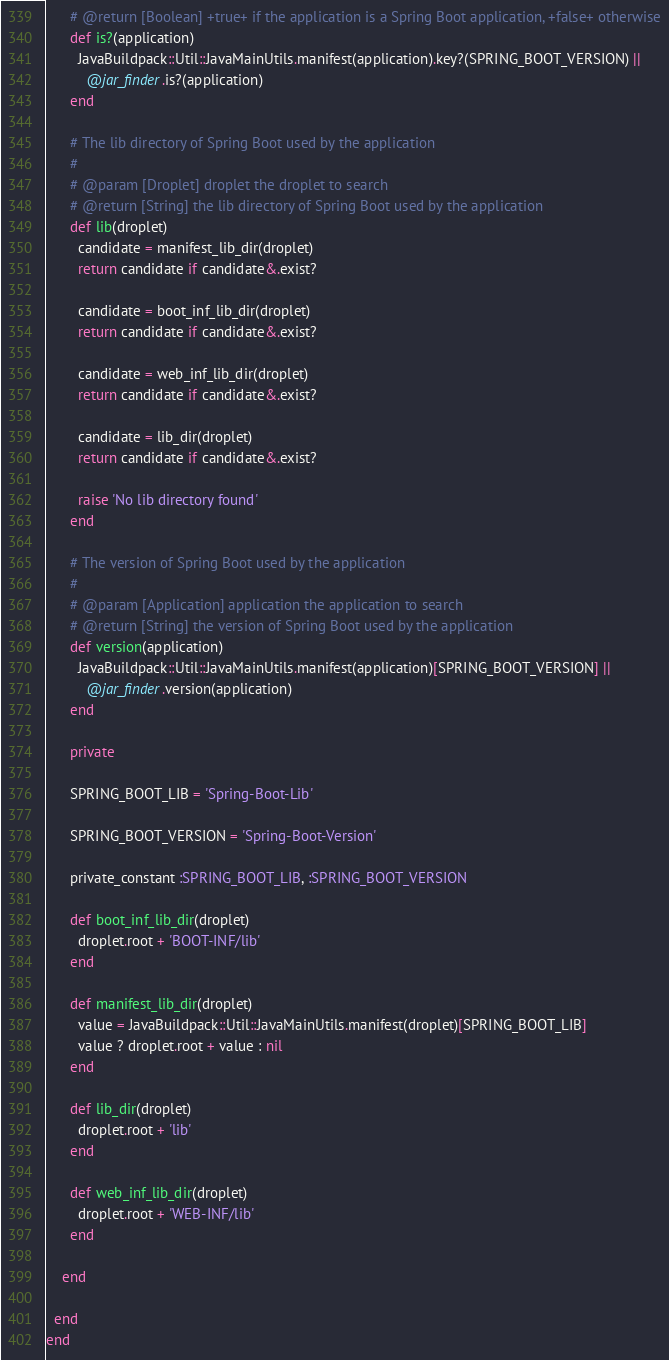Convert code to text. <code><loc_0><loc_0><loc_500><loc_500><_Ruby_>      # @return [Boolean] +true+ if the application is a Spring Boot application, +false+ otherwise
      def is?(application)
        JavaBuildpack::Util::JavaMainUtils.manifest(application).key?(SPRING_BOOT_VERSION) ||
          @jar_finder.is?(application)
      end

      # The lib directory of Spring Boot used by the application
      #
      # @param [Droplet] droplet the droplet to search
      # @return [String] the lib directory of Spring Boot used by the application
      def lib(droplet)
        candidate = manifest_lib_dir(droplet)
        return candidate if candidate&.exist?

        candidate = boot_inf_lib_dir(droplet)
        return candidate if candidate&.exist?

        candidate = web_inf_lib_dir(droplet)
        return candidate if candidate&.exist?

        candidate = lib_dir(droplet)
        return candidate if candidate&.exist?

        raise 'No lib directory found'
      end

      # The version of Spring Boot used by the application
      #
      # @param [Application] application the application to search
      # @return [String] the version of Spring Boot used by the application
      def version(application)
        JavaBuildpack::Util::JavaMainUtils.manifest(application)[SPRING_BOOT_VERSION] ||
          @jar_finder.version(application)
      end

      private

      SPRING_BOOT_LIB = 'Spring-Boot-Lib'

      SPRING_BOOT_VERSION = 'Spring-Boot-Version'

      private_constant :SPRING_BOOT_LIB, :SPRING_BOOT_VERSION

      def boot_inf_lib_dir(droplet)
        droplet.root + 'BOOT-INF/lib'
      end

      def manifest_lib_dir(droplet)
        value = JavaBuildpack::Util::JavaMainUtils.manifest(droplet)[SPRING_BOOT_LIB]
        value ? droplet.root + value : nil
      end

      def lib_dir(droplet)
        droplet.root + 'lib'
      end

      def web_inf_lib_dir(droplet)
        droplet.root + 'WEB-INF/lib'
      end

    end

  end
end
</code> 